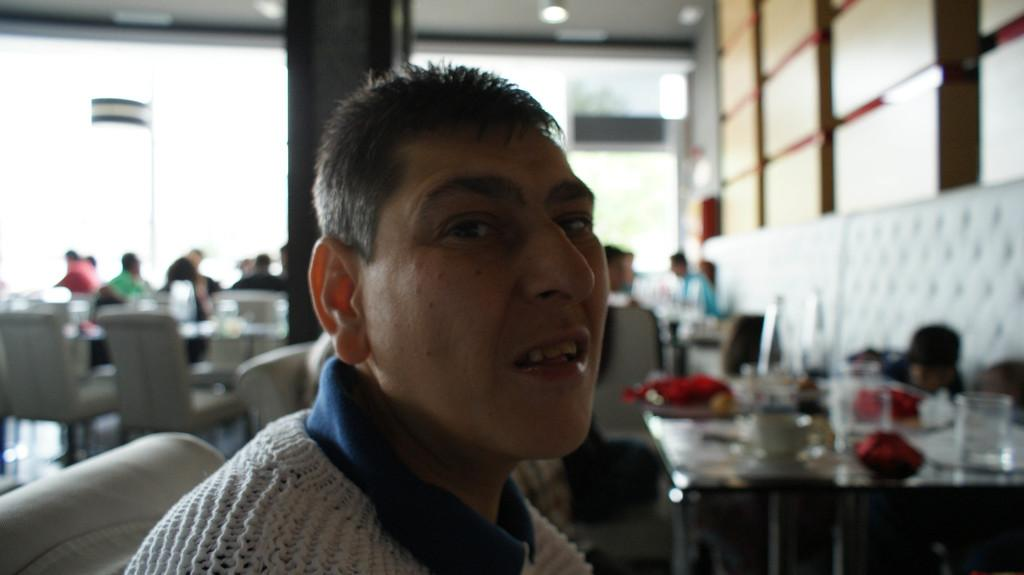Who or what is the main subject of the image? There is a person in the image. What can be observed about the background of the image? The background of the image is blurred. What is the person in the image wearing? The person is wearing clothes. What piece of furniture is visible in the image? There is a table in the bottom right of the image. What type of rhythm can be heard coming from the person in the image? There is no indication of sound or rhythm in the image, as it is a still photograph. 